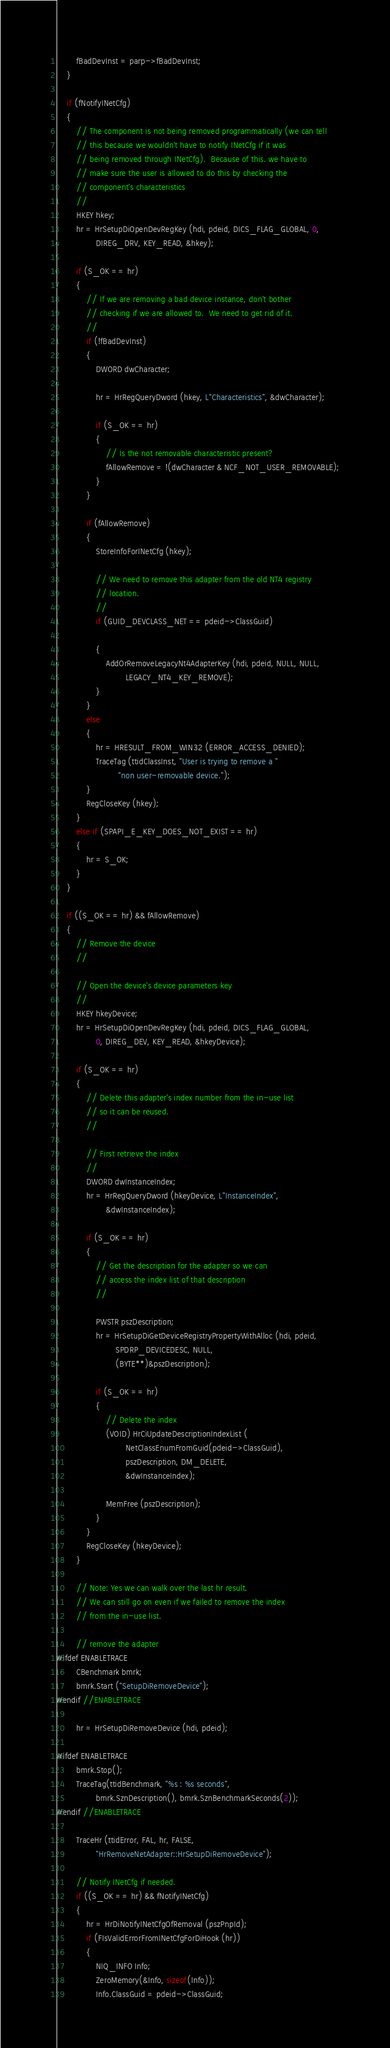Convert code to text. <code><loc_0><loc_0><loc_500><loc_500><_C++_>        fBadDevInst = parp->fBadDevInst;
    }

    if (fNotifyINetCfg)
    {
        // The component is not being removed programmatically (we can tell
        // this because we wouldn't have to notify INetCfg if it was
        // being removed through INetCfg).  Because of this. we have to
        // make sure the user is allowed to do this by checking the
        // component's characteristics
        //
        HKEY hkey;
        hr = HrSetupDiOpenDevRegKey (hdi, pdeid, DICS_FLAG_GLOBAL, 0,
                DIREG_DRV, KEY_READ, &hkey);

        if (S_OK == hr)
        {
            // If we are removing a bad device instance, don't bother
            // checking if we are allowed to.  We need to get rid of it.
            //
            if (!fBadDevInst)
            {
                DWORD dwCharacter;

                hr = HrRegQueryDword (hkey, L"Characteristics", &dwCharacter);

                if (S_OK == hr)
                {
                    // Is the not removable characteristic present?
                    fAllowRemove = !(dwCharacter & NCF_NOT_USER_REMOVABLE);
                }
            }

            if (fAllowRemove)
            {
                StoreInfoForINetCfg (hkey);

                // We need to remove this adapter from the old NT4 registry
                // location.
                //
                if (GUID_DEVCLASS_NET == pdeid->ClassGuid)

                {
                    AddOrRemoveLegacyNt4AdapterKey (hdi, pdeid, NULL, NULL,
                            LEGACY_NT4_KEY_REMOVE);
                }
            }
            else
            {
                hr = HRESULT_FROM_WIN32 (ERROR_ACCESS_DENIED);
                TraceTag (ttidClassInst, "User is trying to remove a "
                         "non user-removable device.");
            }
            RegCloseKey (hkey);
        }
        else if (SPAPI_E_KEY_DOES_NOT_EXIST == hr)
        {
            hr = S_OK;
        }
    }

    if ((S_OK == hr) && fAllowRemove)
    {
        // Remove the device
        //

        // Open the device's device parameters key
        //
        HKEY hkeyDevice;
        hr = HrSetupDiOpenDevRegKey (hdi, pdeid, DICS_FLAG_GLOBAL,
                0, DIREG_DEV, KEY_READ, &hkeyDevice);

        if (S_OK == hr)
        {
            // Delete this adapter's index number from the in-use list
            // so it can be reused.
            //

            // First retrieve the index
            //
            DWORD dwInstanceIndex;
            hr = HrRegQueryDword (hkeyDevice, L"InstanceIndex",
                    &dwInstanceIndex);

            if (S_OK == hr)
            {
                // Get the description for the adapter so we can
                // access the index list of that description
                //

                PWSTR pszDescription;
                hr = HrSetupDiGetDeviceRegistryPropertyWithAlloc (hdi, pdeid,
                        SPDRP_DEVICEDESC, NULL,
                        (BYTE**)&pszDescription);

                if (S_OK == hr)
                {
                    // Delete the index
                    (VOID) HrCiUpdateDescriptionIndexList (
                            NetClassEnumFromGuid(pdeid->ClassGuid),
                            pszDescription, DM_DELETE,
                            &dwInstanceIndex);

                    MemFree (pszDescription);
                }
            }
            RegCloseKey (hkeyDevice);
        }

        // Note: Yes we can walk over the last hr result.
        // We can still go on even if we failed to remove the index
        // from the in-use list.

        // remove the adapter
#ifdef ENABLETRACE
        CBenchmark bmrk;
        bmrk.Start ("SetupDiRemoveDevice");
#endif //ENABLETRACE

        hr = HrSetupDiRemoveDevice (hdi, pdeid);

#ifdef ENABLETRACE
        bmrk.Stop();
        TraceTag(ttidBenchmark, "%s : %s seconds",
                bmrk.SznDescription(), bmrk.SznBenchmarkSeconds(2));
#endif //ENABLETRACE

        TraceHr (ttidError, FAL, hr, FALSE,
                "HrRemoveNetAdapter::HrSetupDiRemoveDevice");

        // Notify INetCfg if needed.
        if ((S_OK == hr) && fNotifyINetCfg)
        {
            hr = HrDiNotifyINetCfgOfRemoval (pszPnpId);
            if (FIsValidErrorFromINetCfgForDiHook (hr))
            {
                NIQ_INFO Info;
                ZeroMemory(&Info, sizeof(Info));
                Info.ClassGuid = pdeid->ClassGuid;</code> 